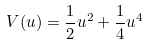<formula> <loc_0><loc_0><loc_500><loc_500>V ( u ) = \frac { 1 } { 2 } u ^ { 2 } + \frac { 1 } { 4 } u ^ { 4 }</formula> 